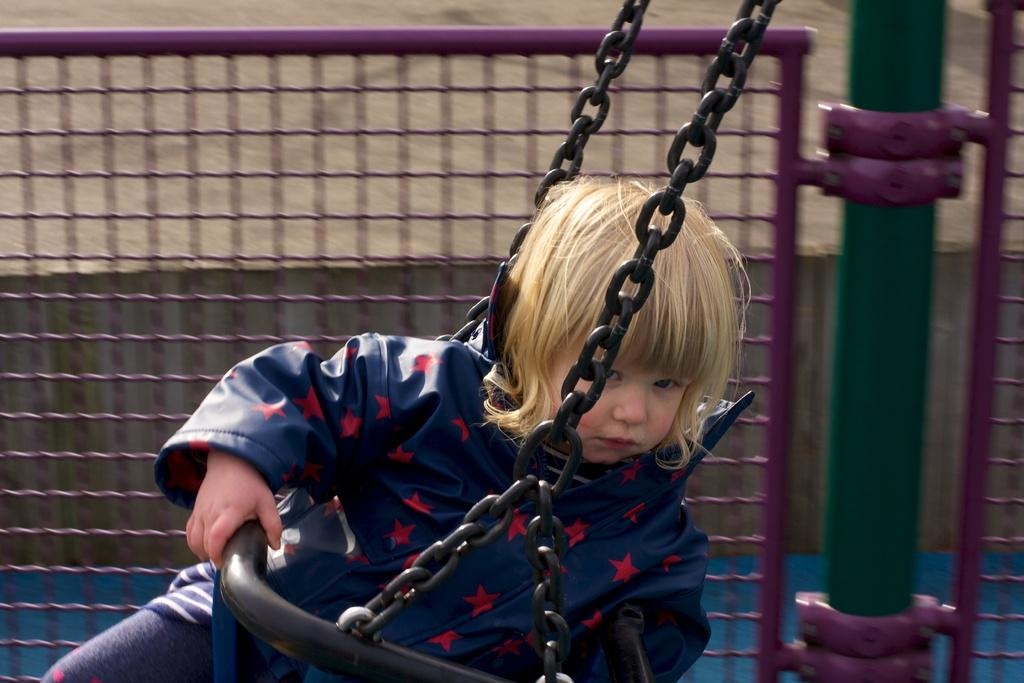Who is the main subject in the image? There is a boy in the image. What is the boy doing in the image? The boy is sitting on a swing. What can be seen in the background of the image? There is a fence visible in the background of the image. How many pizzas are being served on the swing in the image? There are no pizzas present in the image; the boy is sitting on a swing. What type of bottle can be seen on the boy's lap in the image? There is no bottle visible in the image; the boy is sitting on a swing without any visible objects in his lap. 